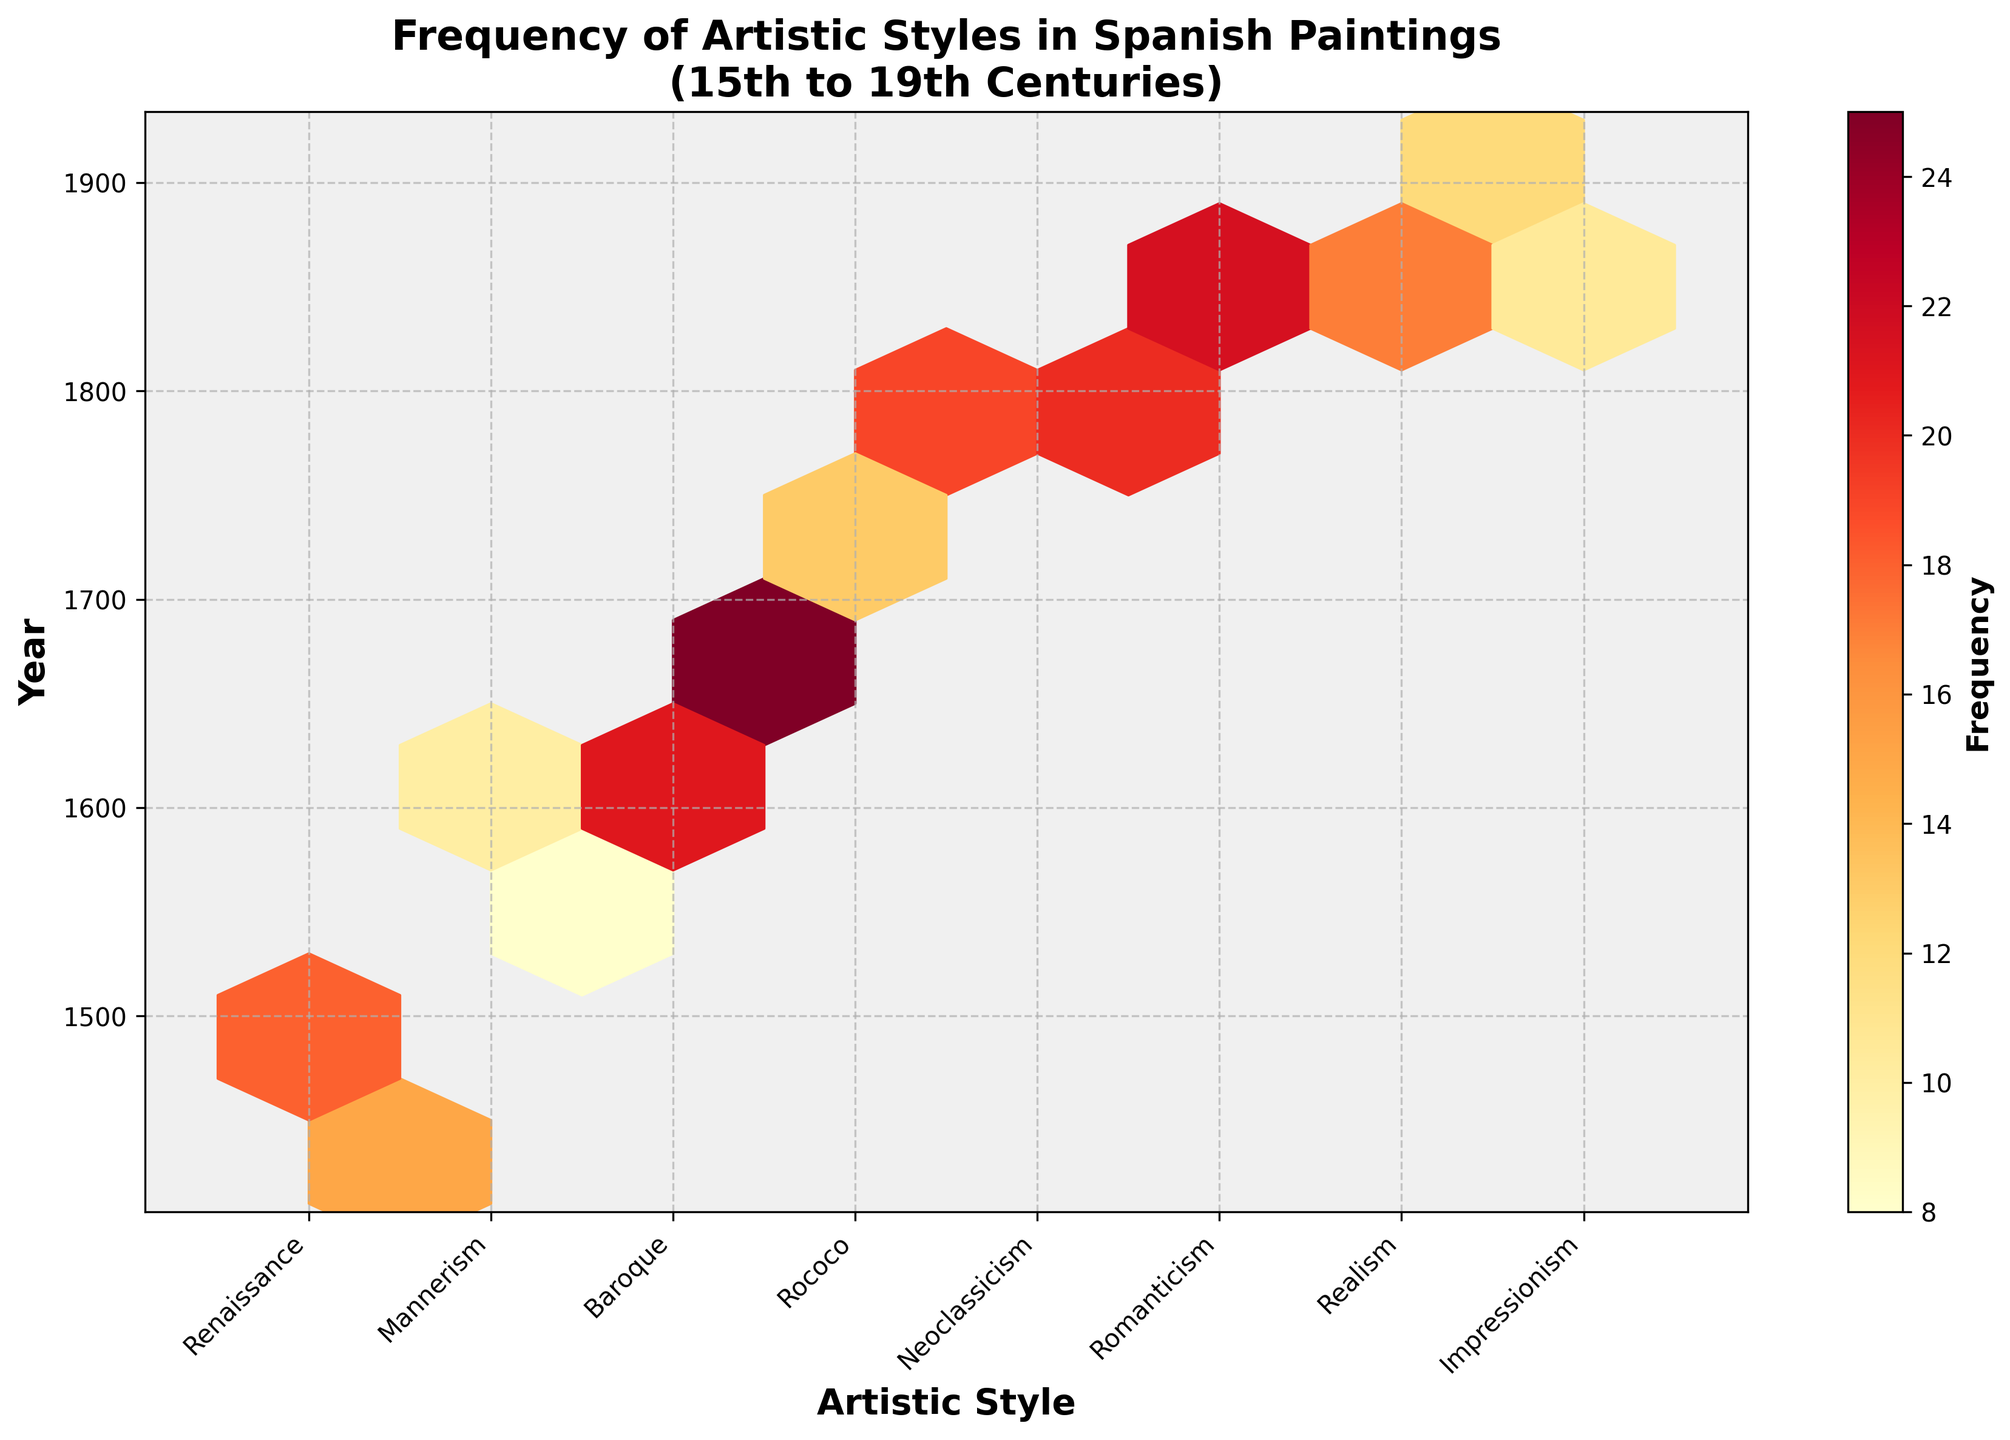what is the title of the plot? The title is usually displayed at the top of the plot and summarizes what the plot is about. In this case, the title clearly indicates the topic and time span.
Answer: Frequency of Artistic Styles in Spanish Paintings (15th to 19th Centuries) Which artistic style has the highest frequency of paintings in the 1600s? To find this, look at the hexagons representing the 1600s and identify the one with the highest color intensity within that range, which signifies the Baroque period.
Answer: Baroque What is the range of years shown on the vertical axis? The vertical axis displays the years associated with different artistic styles of paintings, ranging from the earliest to the latest year. They are in the figure, usually at the edges of the axis.
Answer: 1450 to 1890 Which period has a higher frequency of paintings, Romanticism in the 1800s or Realism in the mid-1800s? Compare the color intensity of the hexagons representing Romanticism in the 1800s to those representing Realism in the mid-1800s. The Romanticism has darker hexagons.
Answer: Romanticism in the 1800s On average, how frequently did Renaissance paintings appear between 1450 and 1500? Renaissance spans from 1450 to 1500. Sum the frequency counts (15 + 18) and divide by the number of periods (2) in that range: (15 + 18)/2 = 16.5
Answer: 16.5 Which artistic style appears to have emerged most recently, based on the data? The most recent period can be identified by looking at the highest year values. Impressionism appears in 1870 to 1890.
Answer: Impressionism Compare the frequency of Neoclassicism paintings in the 1780s to the frequency of Neoclassicism paintings in 1790s. Which period had more paintings? Find the hexagons for Neoclassicism in the 1780s and 1790s and compare their frequencies, respectively 18 in 1780 and 19 in 1790.
Answer: Neoclassicism paintings in the 1790s Are there more paintings from the 1700s or the 1800s? Sum the frequencies of hexagons corresponding to each century. For the 1700s: 12 + 14 + 13 = 39; For the 1800s: 20 + 22 + 18 + 10 + 12 + 11 = 93. Compare the totals.
Answer: 1800s Which artistic style period experienced a decline in painting frequency over time? Look for periods where the hexagon color lightens over successive time points. Mannerism shows fewer paintings over time from 1550 to 1580.
Answer: Mannerism 